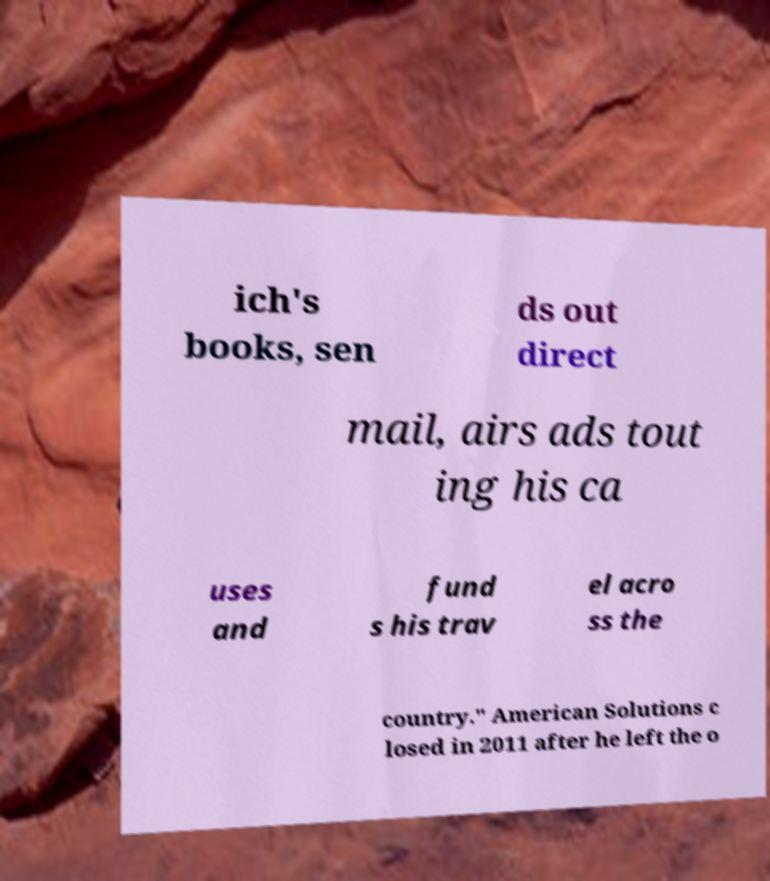Could you extract and type out the text from this image? ich's books, sen ds out direct mail, airs ads tout ing his ca uses and fund s his trav el acro ss the country." American Solutions c losed in 2011 after he left the o 